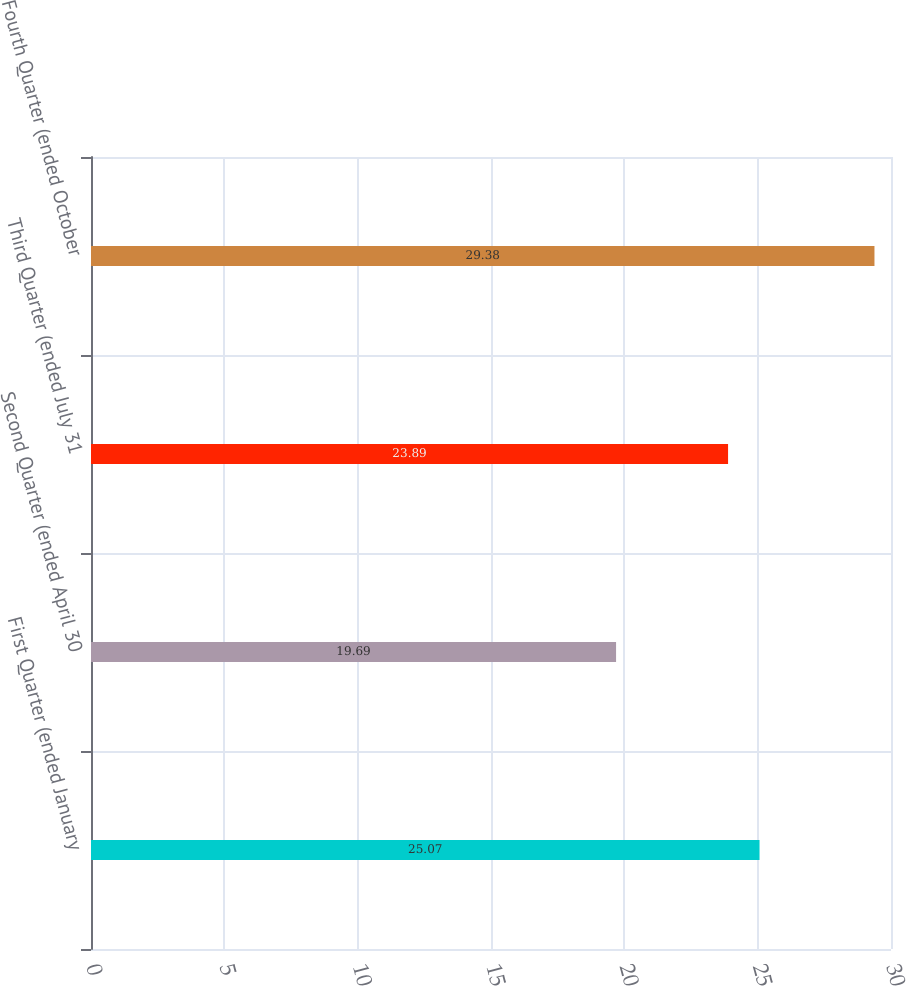<chart> <loc_0><loc_0><loc_500><loc_500><bar_chart><fcel>First Quarter (ended January<fcel>Second Quarter (ended April 30<fcel>Third Quarter (ended July 31<fcel>Fourth Quarter (ended October<nl><fcel>25.07<fcel>19.69<fcel>23.89<fcel>29.38<nl></chart> 